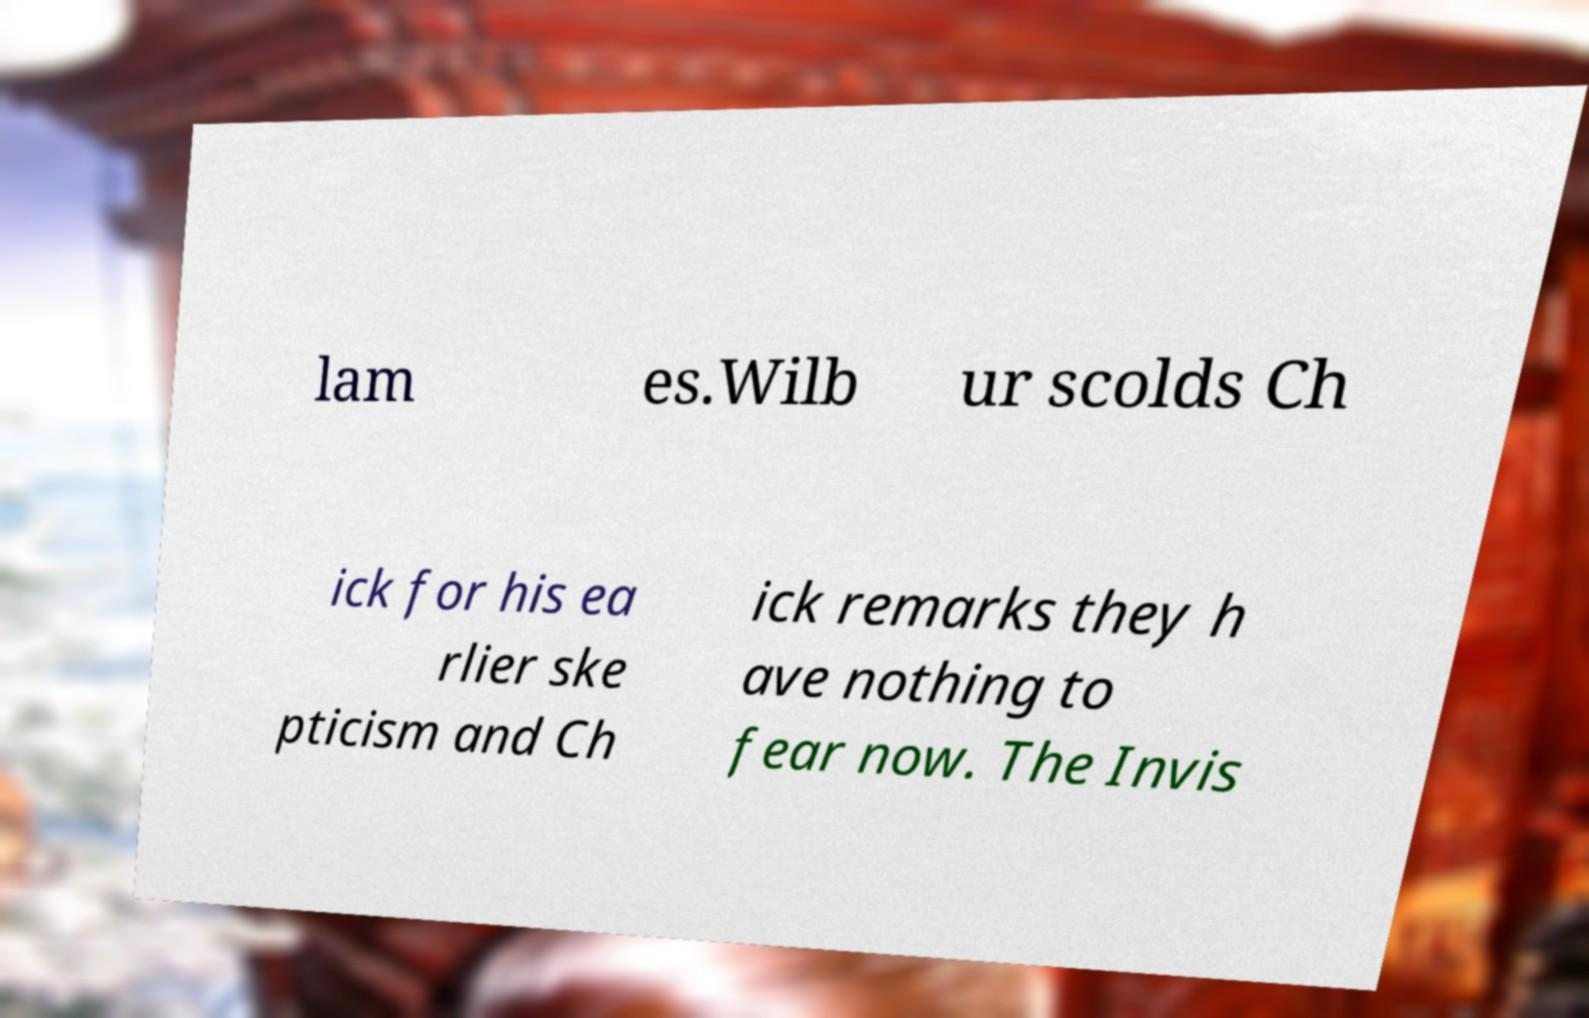Could you extract and type out the text from this image? lam es.Wilb ur scolds Ch ick for his ea rlier ske pticism and Ch ick remarks they h ave nothing to fear now. The Invis 